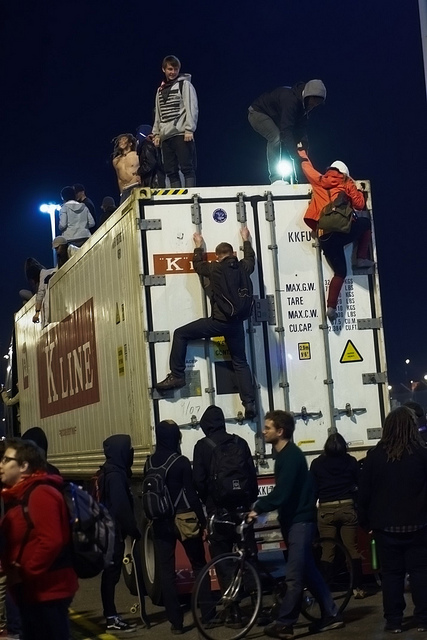How many people are there? There are at least 10 people visible, with several climbing and standing on the container, and others standing or walking around it, indicating a dynamic and possibly spontaneous gathering. 